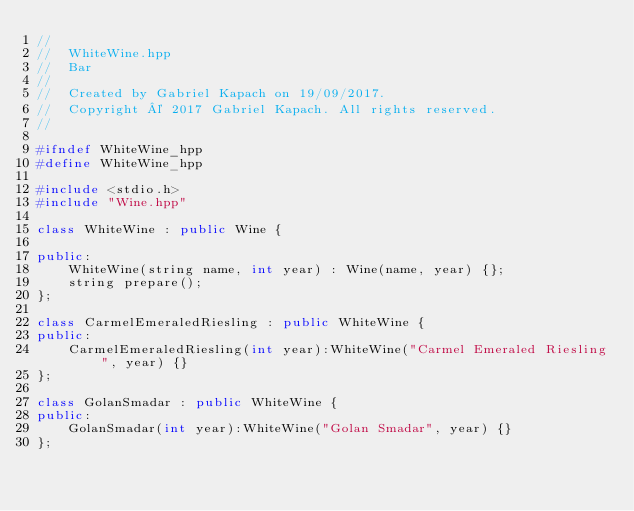Convert code to text. <code><loc_0><loc_0><loc_500><loc_500><_C++_>//
//  WhiteWine.hpp
//  Bar
//
//  Created by Gabriel Kapach on 19/09/2017.
//  Copyright © 2017 Gabriel Kapach. All rights reserved.
//

#ifndef WhiteWine_hpp
#define WhiteWine_hpp

#include <stdio.h>
#include "Wine.hpp"

class WhiteWine : public Wine {
    
public:
    WhiteWine(string name, int year) : Wine(name, year) {};
    string prepare();
};

class CarmelEmeraledRiesling : public WhiteWine {
public:
    CarmelEmeraledRiesling(int year):WhiteWine("Carmel Emeraled Riesling", year) {}
};

class GolanSmadar : public WhiteWine {
public:
    GolanSmadar(int year):WhiteWine("Golan Smadar", year) {}
};
</code> 